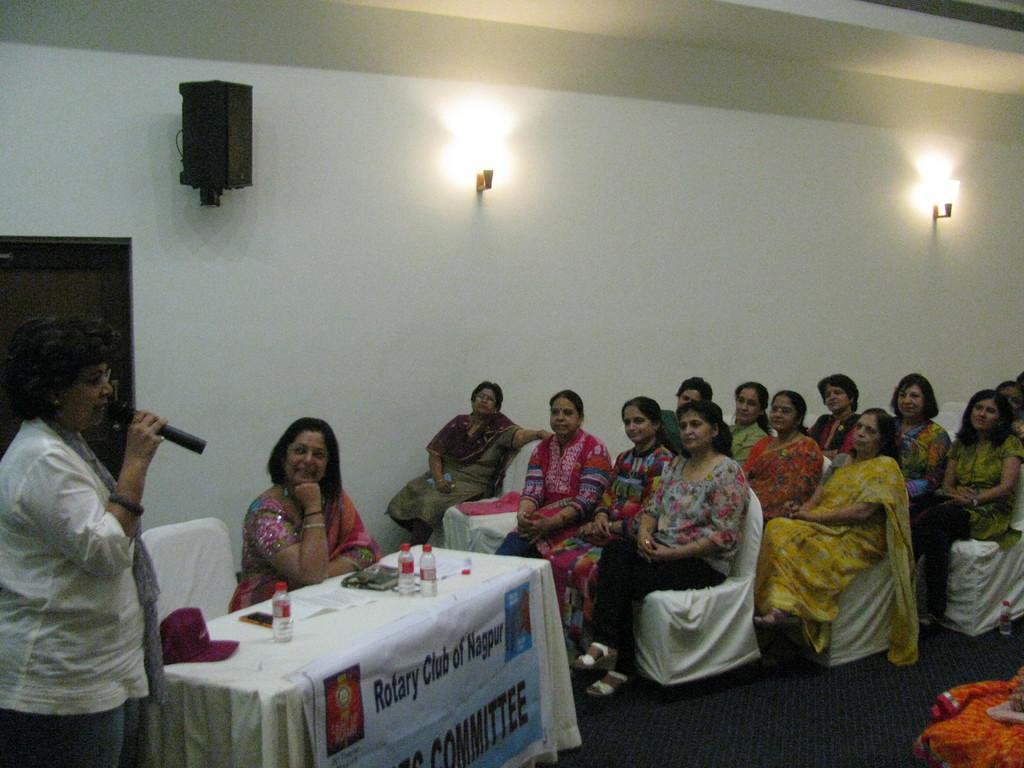How would you summarize this image in a sentence or two? In this image in this room there are so many women are sitting on the chair and some woman is talking and holding the mike the room has many chairs and table and the table has books,hat,phone and papers and some speakers and lights are hanging on the wall. 